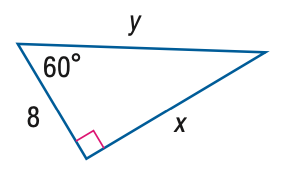Question: Find x.
Choices:
A. 8
B. 11.3
C. 13.9
D. 16
Answer with the letter. Answer: C Question: Find y.
Choices:
A. 8
B. 11.3
C. 13.9
D. 16
Answer with the letter. Answer: D 